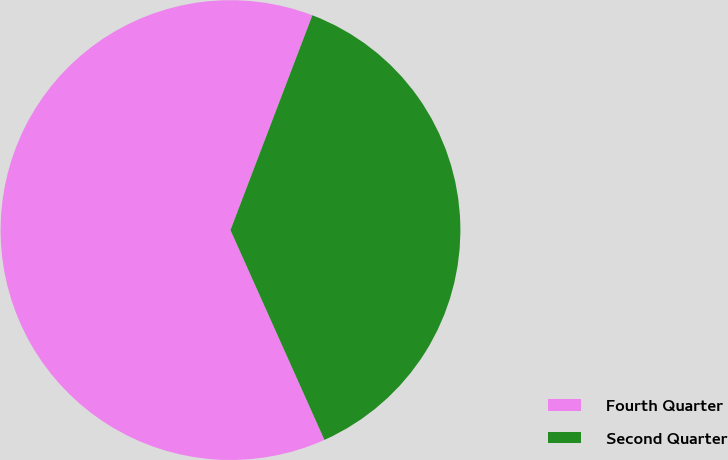Convert chart to OTSL. <chart><loc_0><loc_0><loc_500><loc_500><pie_chart><fcel>Fourth Quarter<fcel>Second Quarter<nl><fcel>62.5%<fcel>37.5%<nl></chart> 